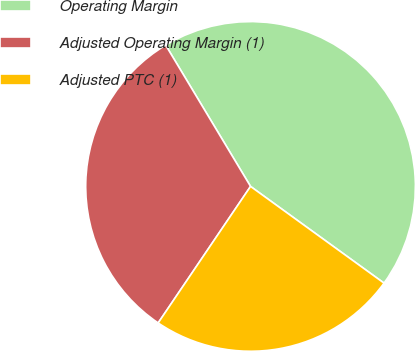<chart> <loc_0><loc_0><loc_500><loc_500><pie_chart><fcel>Operating Margin<fcel>Adjusted Operating Margin (1)<fcel>Adjusted PTC (1)<nl><fcel>43.59%<fcel>31.92%<fcel>24.49%<nl></chart> 